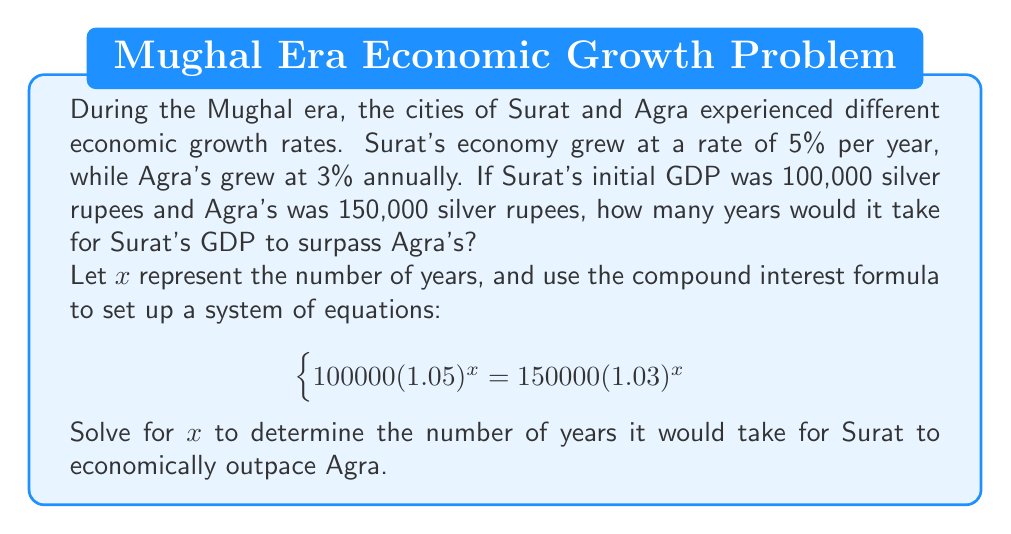Could you help me with this problem? To solve this problem, we'll use the given system of equation and follow these steps:

1) Start with the equation:
   $$100000(1.05)^x = 150000(1.03)^x$$

2) Divide both sides by 100000:
   $$(1.05)^x = 1.5(1.03)^x$$

3) Take the natural log of both sides:
   $$x \ln(1.05) = \ln(1.5) + x \ln(1.03)$$

4) Distribute the $x$ on the right side:
   $$x \ln(1.05) = \ln(1.5) + x \ln(1.03)$$

5) Subtract $x \ln(1.03)$ from both sides:
   $$x \ln(1.05) - x \ln(1.03) = \ln(1.5)$$

6) Factor out $x$:
   $$x(\ln(1.05) - \ln(1.03)) = \ln(1.5)$$

7) Divide both sides by $(\ln(1.05) - \ln(1.03))$:
   $$x = \frac{\ln(1.5)}{\ln(1.05) - \ln(1.03)}$$

8) Calculate the result:
   $$x \approx 16.02$$

9) Since we're dealing with whole years, we round up to the next integer.

This solution aligns with the historical context of Surat's rapid economic growth during the Mughal era, particularly due to its importance as a major port city.
Answer: It would take 17 years for Surat's GDP to surpass Agra's. 